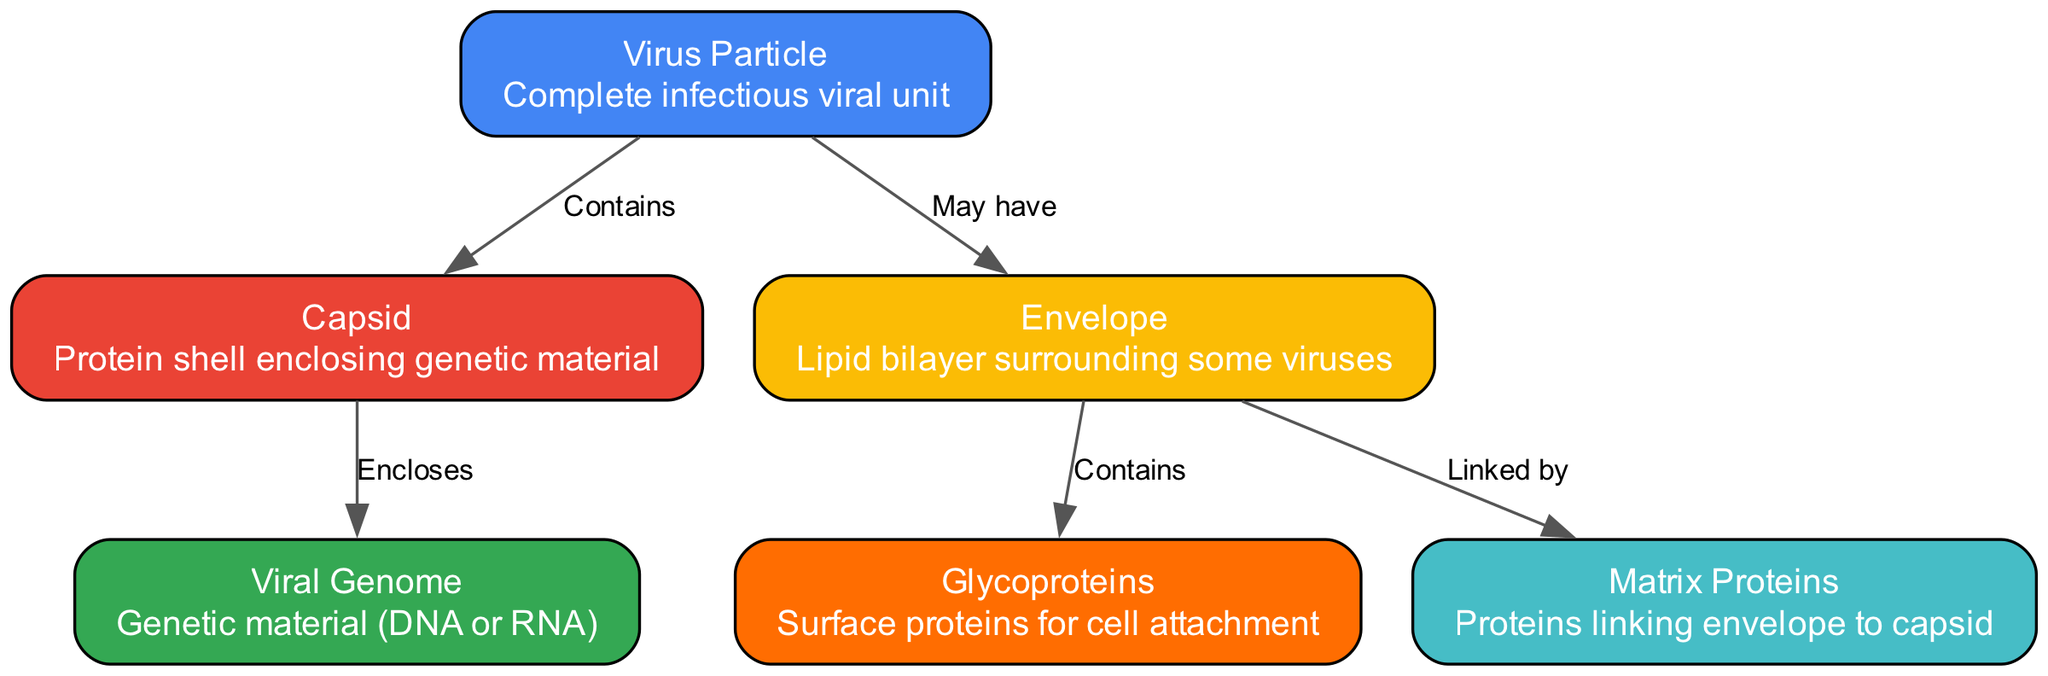What does the capsid do? The capsid encloses the viral genome, providing protection to the genetic material within the virus particle. This relationship is indicated by the edge labeled "Encloses" from the capsid to the genome.
Answer: Encloses genetic material How many nodes are in the diagram? By counting the individual nodes listed, including the virus, capsid, envelope, genome, glycoproteins, and matrix, we find there are a total of six distinct nodes.
Answer: Six What do the glycoproteins do? Glycoproteins are surface proteins found in the envelope that facilitate cell attachment, highlighted by the edge labeled "Contains" from the envelope to glycoproteins.
Answer: Facilitate cell attachment What links the envelope to the capsid? The matrix proteins serve as a connection between the envelope and the capsid, according to the edge labeled "Linked by" that connects the envelope to matrix proteins.
Answer: Matrix proteins How many edges connect the virus to other components? The virus connects to the capsid and may connect to the envelope, resulting in two edges originating from the virus node.
Answer: Two What kind of genetic material does the viral genome represent? The viral genome can be either DNA or RNA, as specified in the description for the genome node.
Answer: DNA or RNA What surrounds the capsid? The capsid is contained within the virus particle, which is the larger structure encompassing it. This is indicated by the edge labeled "Contains" connecting the virus to the capsid.
Answer: Virus particle What is the function of the envelope in the virus structure? The envelope provides a lipid bilayer that surrounds certain viruses, with its description emphasizing its protective and structural role around the virus particle.
Answer: Provide lipid bilayer What color represents the virus in the diagram? The virus is represented in blue, as indicated by the specific color assigned to its node in the diagram.
Answer: Blue 